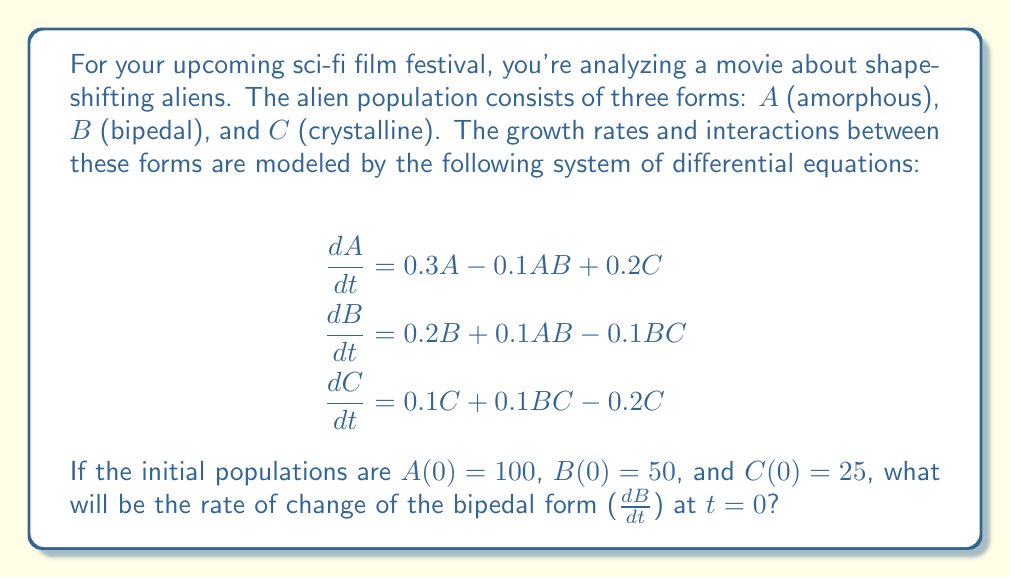Can you solve this math problem? To solve this problem, we need to use the given system of differential equations and the initial population values. We're specifically interested in the rate of change of the bipedal form ($B$) at $t = 0$.

The equation for $\frac{dB}{dt}$ is:

$$\frac{dB}{dt} = 0.2B + 0.1AB - 0.1BC$$

We need to substitute the initial values at $t = 0$:

$A(0) = 100$
$B(0) = 50$
$C(0) = 25$

Let's plug these values into the equation:

$$\begin{aligned}
\frac{dB}{dt} &= 0.2(50) + 0.1(100)(50) - 0.1(50)(25) \\
&= 10 + 500 - 125 \\
&= 10 + 500 - 125 \\
&= 385
\end{aligned}$$

Therefore, at $t = 0$, the rate of change of the bipedal form is 385 aliens per unit time.
Answer: $\frac{dB}{dt} = 385$ aliens per unit time at $t = 0$ 